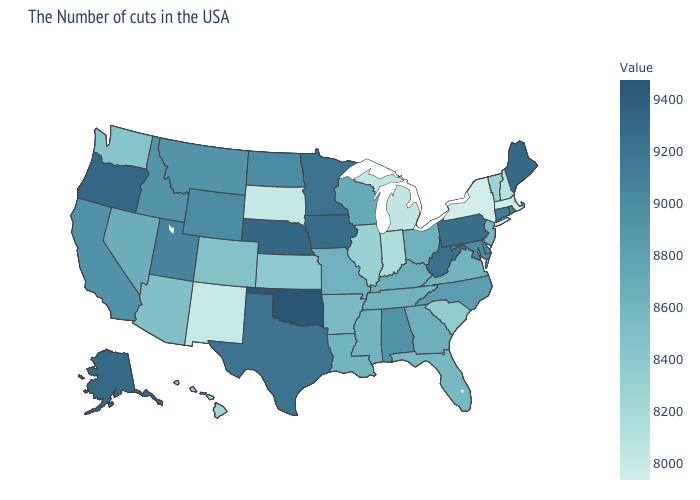Among the states that border Iowa , does Missouri have the highest value?
Answer briefly. No. Is the legend a continuous bar?
Keep it brief. Yes. Among the states that border North Carolina , does Georgia have the highest value?
Keep it brief. Yes. Among the states that border Kansas , does Oklahoma have the lowest value?
Write a very short answer. No. Does the map have missing data?
Answer briefly. No. Which states have the lowest value in the USA?
Keep it brief. New York. Which states have the lowest value in the South?
Concise answer only. South Carolina. Which states have the lowest value in the USA?
Concise answer only. New York. Does Maine have the highest value in the Northeast?
Keep it brief. Yes. 